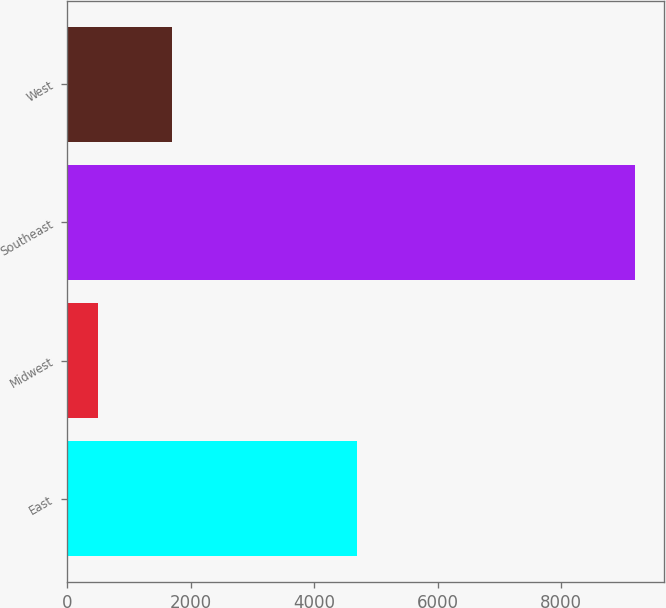Convert chart. <chart><loc_0><loc_0><loc_500><loc_500><bar_chart><fcel>East<fcel>Midwest<fcel>Southeast<fcel>West<nl><fcel>4700<fcel>500<fcel>9200<fcel>1700<nl></chart> 